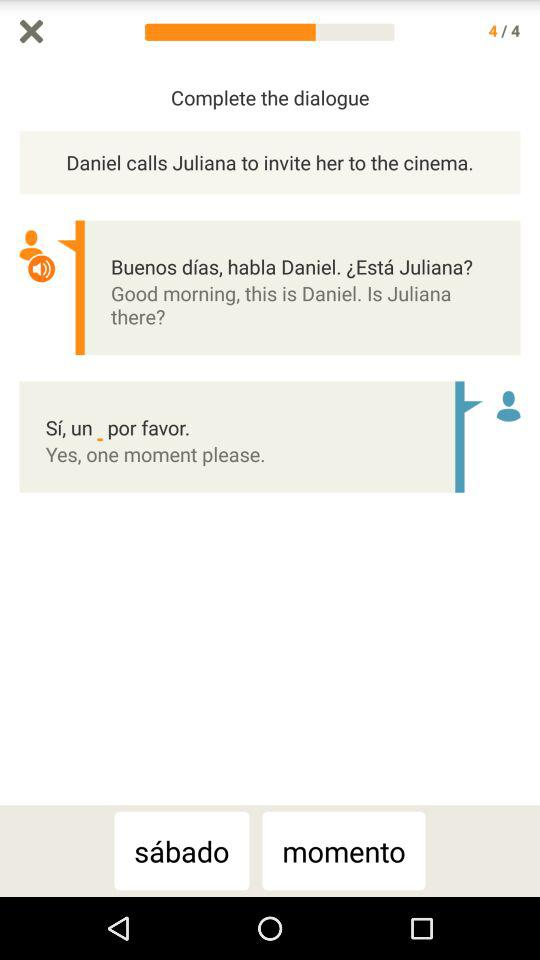How many questions are available? There are 4 available questions. 